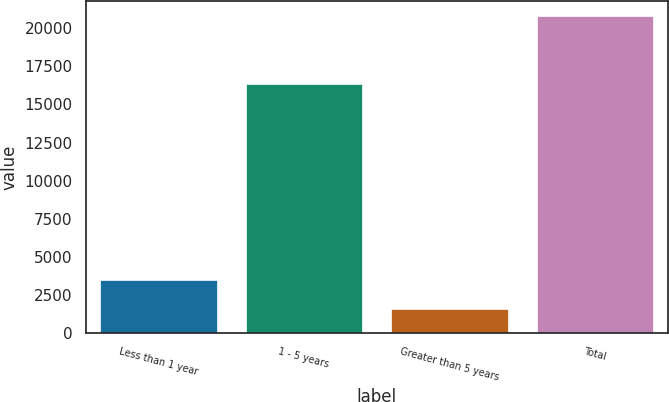<chart> <loc_0><loc_0><loc_500><loc_500><bar_chart><fcel>Less than 1 year<fcel>1 - 5 years<fcel>Greater than 5 years<fcel>Total<nl><fcel>3487.8<fcel>16327<fcel>1567<fcel>20775<nl></chart> 